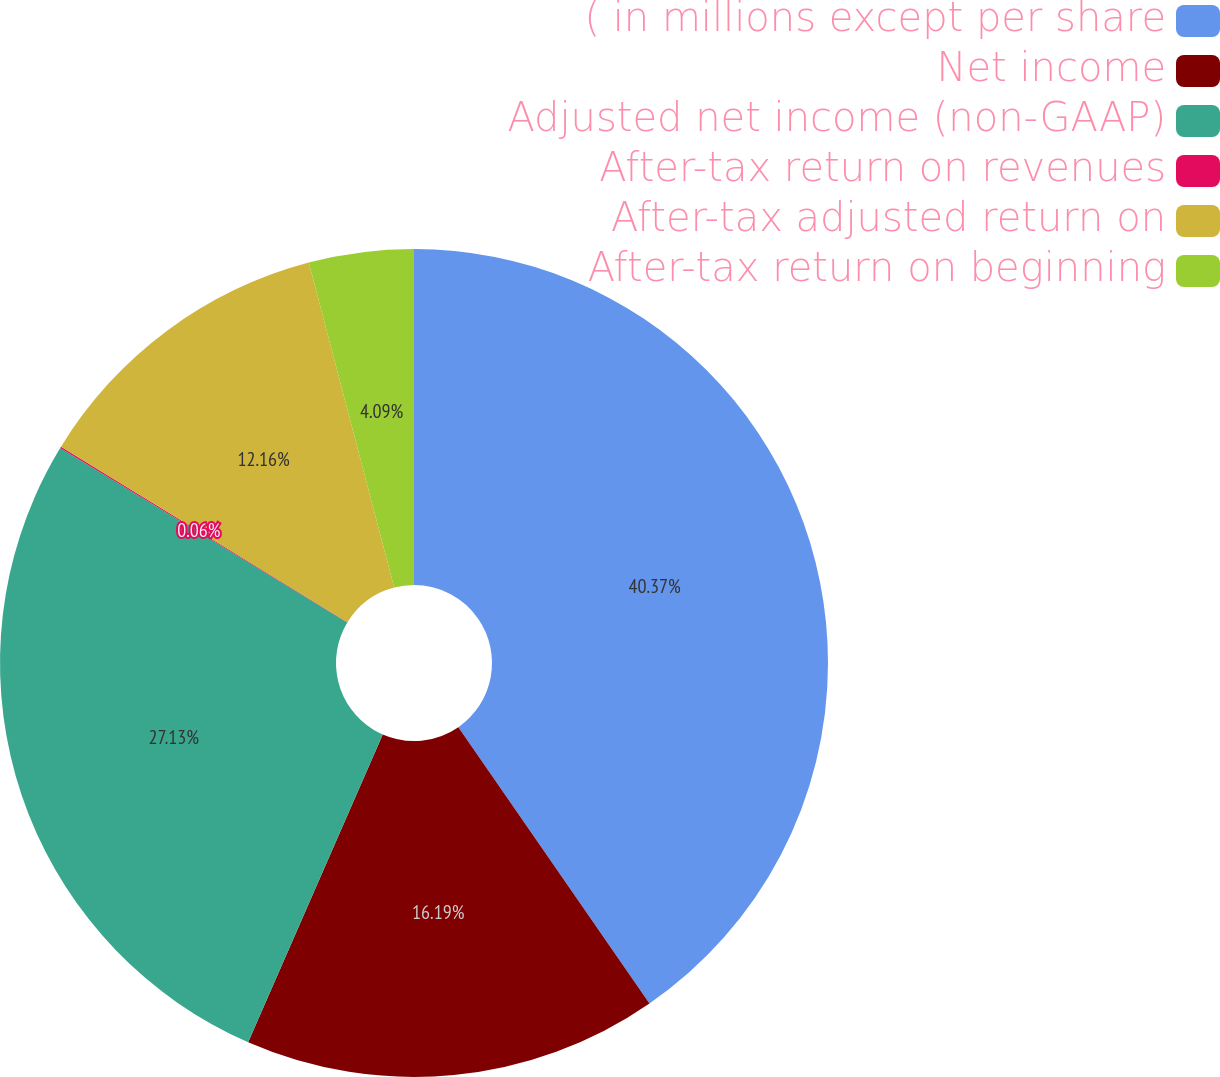<chart> <loc_0><loc_0><loc_500><loc_500><pie_chart><fcel>( in millions except per share<fcel>Net income<fcel>Adjusted net income (non-GAAP)<fcel>After-tax return on revenues<fcel>After-tax adjusted return on<fcel>After-tax return on beginning<nl><fcel>40.37%<fcel>16.19%<fcel>27.13%<fcel>0.06%<fcel>12.16%<fcel>4.09%<nl></chart> 